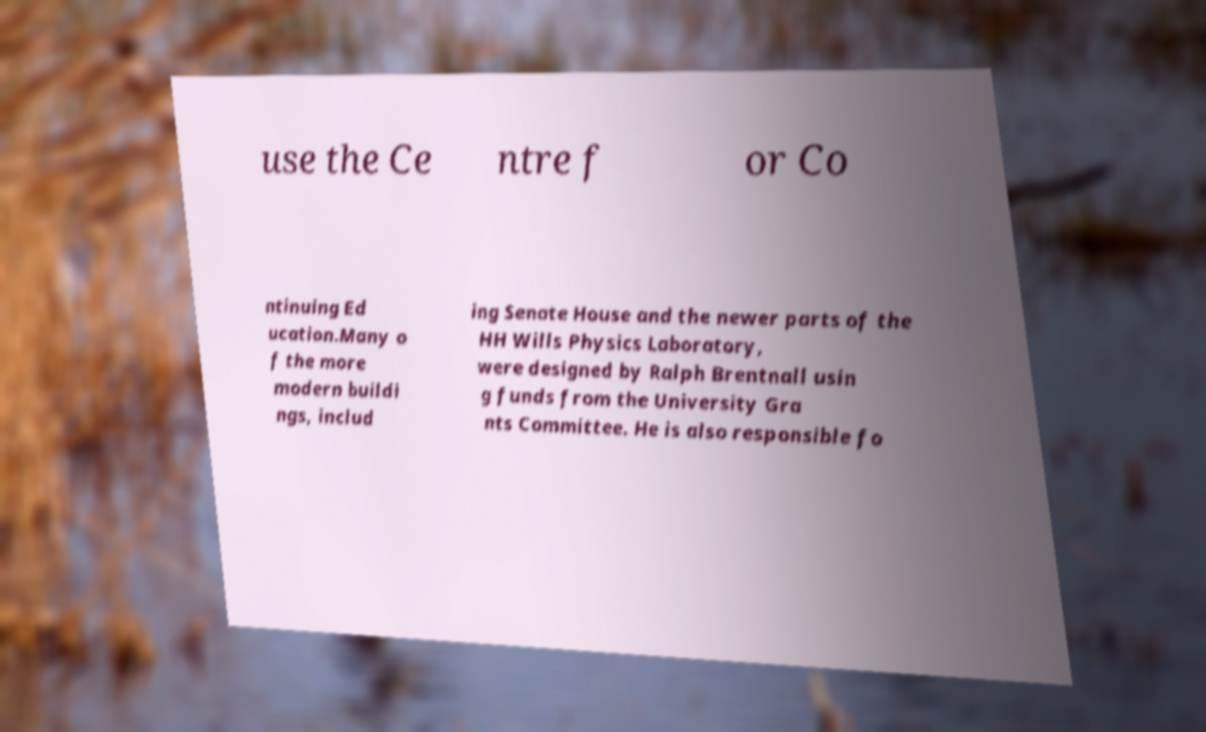Please read and relay the text visible in this image. What does it say? use the Ce ntre f or Co ntinuing Ed ucation.Many o f the more modern buildi ngs, includ ing Senate House and the newer parts of the HH Wills Physics Laboratory, were designed by Ralph Brentnall usin g funds from the University Gra nts Committee. He is also responsible fo 